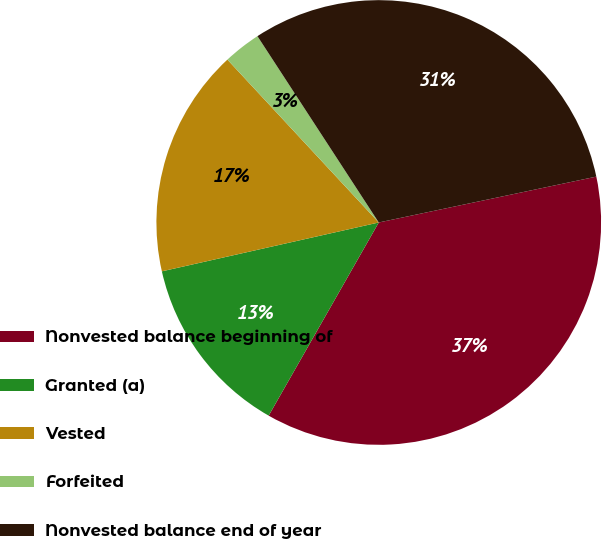<chart> <loc_0><loc_0><loc_500><loc_500><pie_chart><fcel>Nonvested balance beginning of<fcel>Granted (a)<fcel>Vested<fcel>Forfeited<fcel>Nonvested balance end of year<nl><fcel>36.55%<fcel>13.23%<fcel>16.61%<fcel>2.73%<fcel>30.88%<nl></chart> 